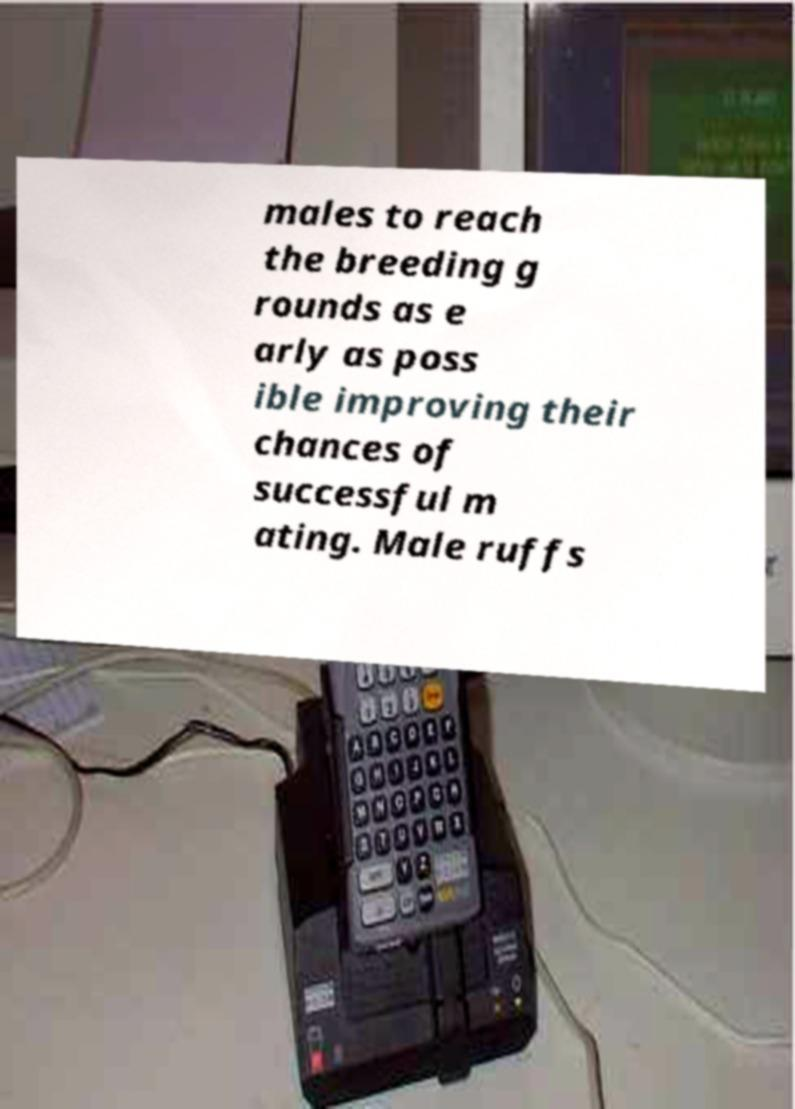Could you extract and type out the text from this image? males to reach the breeding g rounds as e arly as poss ible improving their chances of successful m ating. Male ruffs 